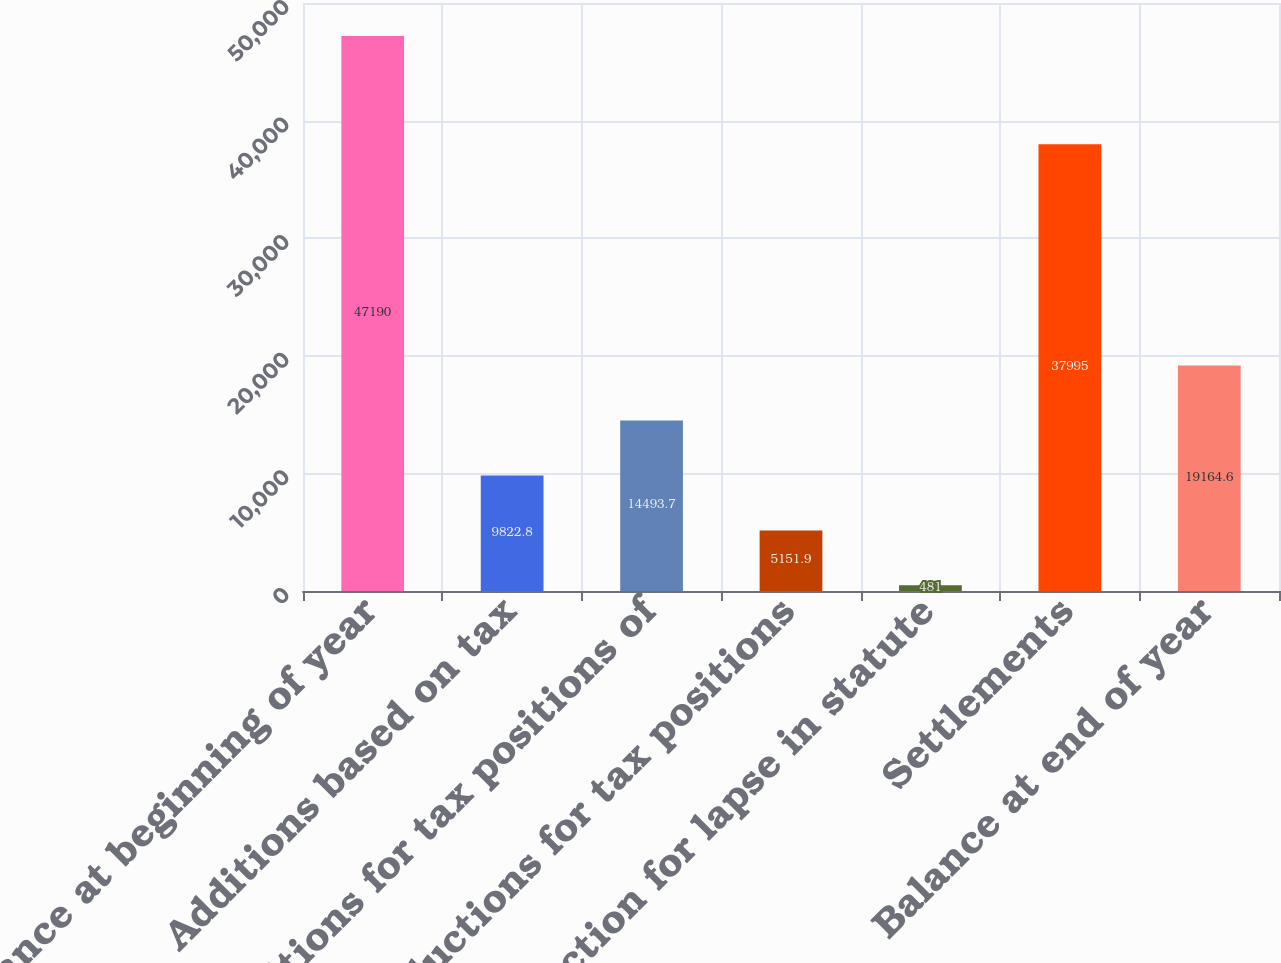Convert chart to OTSL. <chart><loc_0><loc_0><loc_500><loc_500><bar_chart><fcel>Balance at beginning of year<fcel>Additions based on tax<fcel>Additions for tax positions of<fcel>Reductions for tax positions<fcel>Reduction for lapse in statute<fcel>Settlements<fcel>Balance at end of year<nl><fcel>47190<fcel>9822.8<fcel>14493.7<fcel>5151.9<fcel>481<fcel>37995<fcel>19164.6<nl></chart> 